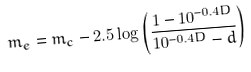Convert formula to latex. <formula><loc_0><loc_0><loc_500><loc_500>m _ { e } = m _ { c } - 2 . 5 \log \left ( \frac { 1 - 1 0 ^ { - 0 . 4 D } } { 1 0 ^ { - 0 . 4 D } - d } \right )</formula> 